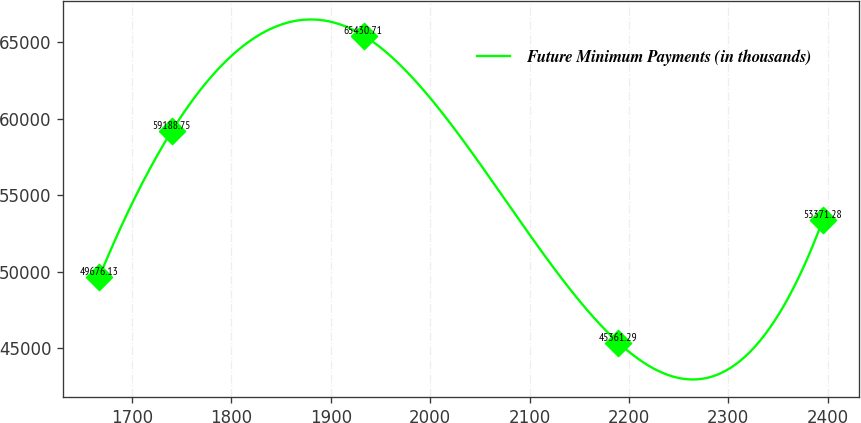Convert chart to OTSL. <chart><loc_0><loc_0><loc_500><loc_500><line_chart><ecel><fcel>Future Minimum Payments (in thousands)<nl><fcel>1667.13<fcel>49676.1<nl><fcel>1739.92<fcel>59188.8<nl><fcel>1932.91<fcel>65430.7<nl><fcel>2189.42<fcel>45361.3<nl><fcel>2395.02<fcel>53371.3<nl></chart> 